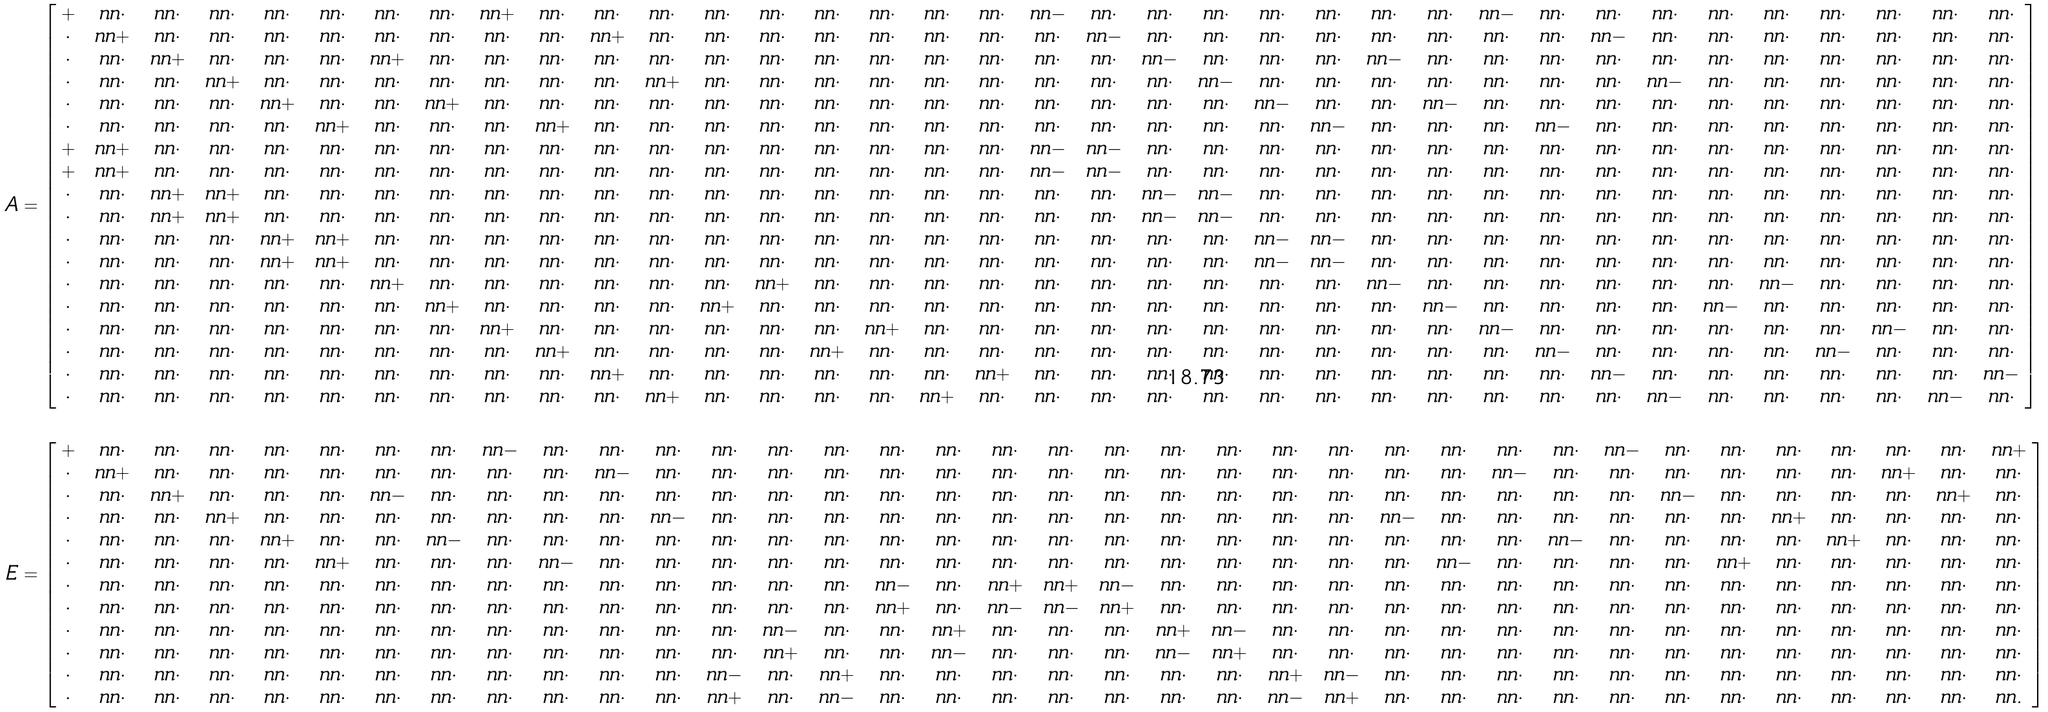<formula> <loc_0><loc_0><loc_500><loc_500>A & = \left [ \begin{array} { c c c c c c c c c c c c c c c c c c c c c c c c c c c c c c c c c c c c } + & \ n n \cdot & \ n n \cdot & \ n n \cdot & \ n n \cdot & \ n n \cdot & \ n n \cdot & \ n n \cdot & \ n n + & \ n n \cdot & \ n n \cdot & \ n n \cdot & \ n n \cdot & \ n n \cdot & \ n n \cdot & \ n n \cdot & \ n n \cdot & \ n n \cdot & \ n n - & \ n n \cdot & \ n n \cdot & \ n n \cdot & \ n n \cdot & \ n n \cdot & \ n n \cdot & \ n n \cdot & \ n n - & \ n n \cdot & \ n n \cdot & \ n n \cdot & \ n n \cdot & \ n n \cdot & \ n n \cdot & \ n n \cdot & \ n n \cdot & \ n n \cdot \\ \cdot & \ n n + & \ n n \cdot & \ n n \cdot & \ n n \cdot & \ n n \cdot & \ n n \cdot & \ n n \cdot & \ n n \cdot & \ n n \cdot & \ n n + & \ n n \cdot & \ n n \cdot & \ n n \cdot & \ n n \cdot & \ n n \cdot & \ n n \cdot & \ n n \cdot & \ n n \cdot & \ n n - & \ n n \cdot & \ n n \cdot & \ n n \cdot & \ n n \cdot & \ n n \cdot & \ n n \cdot & \ n n \cdot & \ n n \cdot & \ n n - & \ n n \cdot & \ n n \cdot & \ n n \cdot & \ n n \cdot & \ n n \cdot & \ n n \cdot & \ n n \cdot \\ \cdot & \ n n \cdot & \ n n + & \ n n \cdot & \ n n \cdot & \ n n \cdot & \ n n + & \ n n \cdot & \ n n \cdot & \ n n \cdot & \ n n \cdot & \ n n \cdot & \ n n \cdot & \ n n \cdot & \ n n \cdot & \ n n \cdot & \ n n \cdot & \ n n \cdot & \ n n \cdot & \ n n \cdot & \ n n - & \ n n \cdot & \ n n \cdot & \ n n \cdot & \ n n - & \ n n \cdot & \ n n \cdot & \ n n \cdot & \ n n \cdot & \ n n \cdot & \ n n \cdot & \ n n \cdot & \ n n \cdot & \ n n \cdot & \ n n \cdot & \ n n \cdot \\ \cdot & \ n n \cdot & \ n n \cdot & \ n n + & \ n n \cdot & \ n n \cdot & \ n n \cdot & \ n n \cdot & \ n n \cdot & \ n n \cdot & \ n n \cdot & \ n n + & \ n n \cdot & \ n n \cdot & \ n n \cdot & \ n n \cdot & \ n n \cdot & \ n n \cdot & \ n n \cdot & \ n n \cdot & \ n n \cdot & \ n n - & \ n n \cdot & \ n n \cdot & \ n n \cdot & \ n n \cdot & \ n n \cdot & \ n n \cdot & \ n n \cdot & \ n n - & \ n n \cdot & \ n n \cdot & \ n n \cdot & \ n n \cdot & \ n n \cdot & \ n n \cdot \\ \cdot & \ n n \cdot & \ n n \cdot & \ n n \cdot & \ n n + & \ n n \cdot & \ n n \cdot & \ n n + & \ n n \cdot & \ n n \cdot & \ n n \cdot & \ n n \cdot & \ n n \cdot & \ n n \cdot & \ n n \cdot & \ n n \cdot & \ n n \cdot & \ n n \cdot & \ n n \cdot & \ n n \cdot & \ n n \cdot & \ n n \cdot & \ n n - & \ n n \cdot & \ n n \cdot & \ n n - & \ n n \cdot & \ n n \cdot & \ n n \cdot & \ n n \cdot & \ n n \cdot & \ n n \cdot & \ n n \cdot & \ n n \cdot & \ n n \cdot & \ n n \cdot \\ \cdot & \ n n \cdot & \ n n \cdot & \ n n \cdot & \ n n \cdot & \ n n + & \ n n \cdot & \ n n \cdot & \ n n \cdot & \ n n + & \ n n \cdot & \ n n \cdot & \ n n \cdot & \ n n \cdot & \ n n \cdot & \ n n \cdot & \ n n \cdot & \ n n \cdot & \ n n \cdot & \ n n \cdot & \ n n \cdot & \ n n \cdot & \ n n \cdot & \ n n - & \ n n \cdot & \ n n \cdot & \ n n \cdot & \ n n - & \ n n \cdot & \ n n \cdot & \ n n \cdot & \ n n \cdot & \ n n \cdot & \ n n \cdot & \ n n \cdot & \ n n \cdot \\ + & \ n n + & \ n n \cdot & \ n n \cdot & \ n n \cdot & \ n n \cdot & \ n n \cdot & \ n n \cdot & \ n n \cdot & \ n n \cdot & \ n n \cdot & \ n n \cdot & \ n n \cdot & \ n n \cdot & \ n n \cdot & \ n n \cdot & \ n n \cdot & \ n n \cdot & \ n n - & \ n n - & \ n n \cdot & \ n n \cdot & \ n n \cdot & \ n n \cdot & \ n n \cdot & \ n n \cdot & \ n n \cdot & \ n n \cdot & \ n n \cdot & \ n n \cdot & \ n n \cdot & \ n n \cdot & \ n n \cdot & \ n n \cdot & \ n n \cdot & \ n n \cdot \\ + & \ n n + & \ n n \cdot & \ n n \cdot & \ n n \cdot & \ n n \cdot & \ n n \cdot & \ n n \cdot & \ n n \cdot & \ n n \cdot & \ n n \cdot & \ n n \cdot & \ n n \cdot & \ n n \cdot & \ n n \cdot & \ n n \cdot & \ n n \cdot & \ n n \cdot & \ n n - & \ n n - & \ n n \cdot & \ n n \cdot & \ n n \cdot & \ n n \cdot & \ n n \cdot & \ n n \cdot & \ n n \cdot & \ n n \cdot & \ n n \cdot & \ n n \cdot & \ n n \cdot & \ n n \cdot & \ n n \cdot & \ n n \cdot & \ n n \cdot & \ n n \cdot \\ \cdot & \ n n \cdot & \ n n + & \ n n + & \ n n \cdot & \ n n \cdot & \ n n \cdot & \ n n \cdot & \ n n \cdot & \ n n \cdot & \ n n \cdot & \ n n \cdot & \ n n \cdot & \ n n \cdot & \ n n \cdot & \ n n \cdot & \ n n \cdot & \ n n \cdot & \ n n \cdot & \ n n \cdot & \ n n - & \ n n - & \ n n \cdot & \ n n \cdot & \ n n \cdot & \ n n \cdot & \ n n \cdot & \ n n \cdot & \ n n \cdot & \ n n \cdot & \ n n \cdot & \ n n \cdot & \ n n \cdot & \ n n \cdot & \ n n \cdot & \ n n \cdot \\ \cdot & \ n n \cdot & \ n n + & \ n n + & \ n n \cdot & \ n n \cdot & \ n n \cdot & \ n n \cdot & \ n n \cdot & \ n n \cdot & \ n n \cdot & \ n n \cdot & \ n n \cdot & \ n n \cdot & \ n n \cdot & \ n n \cdot & \ n n \cdot & \ n n \cdot & \ n n \cdot & \ n n \cdot & \ n n - & \ n n - & \ n n \cdot & \ n n \cdot & \ n n \cdot & \ n n \cdot & \ n n \cdot & \ n n \cdot & \ n n \cdot & \ n n \cdot & \ n n \cdot & \ n n \cdot & \ n n \cdot & \ n n \cdot & \ n n \cdot & \ n n \cdot \\ \cdot & \ n n \cdot & \ n n \cdot & \ n n \cdot & \ n n + & \ n n + & \ n n \cdot & \ n n \cdot & \ n n \cdot & \ n n \cdot & \ n n \cdot & \ n n \cdot & \ n n \cdot & \ n n \cdot & \ n n \cdot & \ n n \cdot & \ n n \cdot & \ n n \cdot & \ n n \cdot & \ n n \cdot & \ n n \cdot & \ n n \cdot & \ n n - & \ n n - & \ n n \cdot & \ n n \cdot & \ n n \cdot & \ n n \cdot & \ n n \cdot & \ n n \cdot & \ n n \cdot & \ n n \cdot & \ n n \cdot & \ n n \cdot & \ n n \cdot & \ n n \cdot \\ \cdot & \ n n \cdot & \ n n \cdot & \ n n \cdot & \ n n + & \ n n + & \ n n \cdot & \ n n \cdot & \ n n \cdot & \ n n \cdot & \ n n \cdot & \ n n \cdot & \ n n \cdot & \ n n \cdot & \ n n \cdot & \ n n \cdot & \ n n \cdot & \ n n \cdot & \ n n \cdot & \ n n \cdot & \ n n \cdot & \ n n \cdot & \ n n - & \ n n - & \ n n \cdot & \ n n \cdot & \ n n \cdot & \ n n \cdot & \ n n \cdot & \ n n \cdot & \ n n \cdot & \ n n \cdot & \ n n \cdot & \ n n \cdot & \ n n \cdot & \ n n \cdot \\ \cdot & \ n n \cdot & \ n n \cdot & \ n n \cdot & \ n n \cdot & \ n n \cdot & \ n n + & \ n n \cdot & \ n n \cdot & \ n n \cdot & \ n n \cdot & \ n n \cdot & \ n n \cdot & \ n n + & \ n n \cdot & \ n n \cdot & \ n n \cdot & \ n n \cdot & \ n n \cdot & \ n n \cdot & \ n n \cdot & \ n n \cdot & \ n n \cdot & \ n n \cdot & \ n n - & \ n n \cdot & \ n n \cdot & \ n n \cdot & \ n n \cdot & \ n n \cdot & \ n n \cdot & \ n n - & \ n n \cdot & \ n n \cdot & \ n n \cdot & \ n n \cdot \\ \cdot & \ n n \cdot & \ n n \cdot & \ n n \cdot & \ n n \cdot & \ n n \cdot & \ n n \cdot & \ n n + & \ n n \cdot & \ n n \cdot & \ n n \cdot & \ n n \cdot & \ n n + & \ n n \cdot & \ n n \cdot & \ n n \cdot & \ n n \cdot & \ n n \cdot & \ n n \cdot & \ n n \cdot & \ n n \cdot & \ n n \cdot & \ n n \cdot & \ n n \cdot & \ n n \cdot & \ n n - & \ n n \cdot & \ n n \cdot & \ n n \cdot & \ n n \cdot & \ n n - & \ n n \cdot & \ n n \cdot & \ n n \cdot & \ n n \cdot & \ n n \cdot \\ \cdot & \ n n \cdot & \ n n \cdot & \ n n \cdot & \ n n \cdot & \ n n \cdot & \ n n \cdot & \ n n \cdot & \ n n + & \ n n \cdot & \ n n \cdot & \ n n \cdot & \ n n \cdot & \ n n \cdot & \ n n \cdot & \ n n + & \ n n \cdot & \ n n \cdot & \ n n \cdot & \ n n \cdot & \ n n \cdot & \ n n \cdot & \ n n \cdot & \ n n \cdot & \ n n \cdot & \ n n \cdot & \ n n - & \ n n \cdot & \ n n \cdot & \ n n \cdot & \ n n \cdot & \ n n \cdot & \ n n \cdot & \ n n - & \ n n \cdot & \ n n \cdot \\ \cdot & \ n n \cdot & \ n n \cdot & \ n n \cdot & \ n n \cdot & \ n n \cdot & \ n n \cdot & \ n n \cdot & \ n n \cdot & \ n n + & \ n n \cdot & \ n n \cdot & \ n n \cdot & \ n n \cdot & \ n n + & \ n n \cdot & \ n n \cdot & \ n n \cdot & \ n n \cdot & \ n n \cdot & \ n n \cdot & \ n n \cdot & \ n n \cdot & \ n n \cdot & \ n n \cdot & \ n n \cdot & \ n n \cdot & \ n n - & \ n n \cdot & \ n n \cdot & \ n n \cdot & \ n n \cdot & \ n n - & \ n n \cdot & \ n n \cdot & \ n n \cdot \\ \cdot & \ n n \cdot & \ n n \cdot & \ n n \cdot & \ n n \cdot & \ n n \cdot & \ n n \cdot & \ n n \cdot & \ n n \cdot & \ n n \cdot & \ n n + & \ n n \cdot & \ n n \cdot & \ n n \cdot & \ n n \cdot & \ n n \cdot & \ n n \cdot & \ n n + & \ n n \cdot & \ n n \cdot & \ n n \cdot & \ n n \cdot & \ n n \cdot & \ n n \cdot & \ n n \cdot & \ n n \cdot & \ n n \cdot & \ n n \cdot & \ n n - & \ n n \cdot & \ n n \cdot & \ n n \cdot & \ n n \cdot & \ n n \cdot & \ n n \cdot & \ n n - \\ \cdot & \ n n \cdot & \ n n \cdot & \ n n \cdot & \ n n \cdot & \ n n \cdot & \ n n \cdot & \ n n \cdot & \ n n \cdot & \ n n \cdot & \ n n \cdot & \ n n + & \ n n \cdot & \ n n \cdot & \ n n \cdot & \ n n \cdot & \ n n + & \ n n \cdot & \ n n \cdot & \ n n \cdot & \ n n \cdot & \ n n \cdot & \ n n \cdot & \ n n \cdot & \ n n \cdot & \ n n \cdot & \ n n \cdot & \ n n \cdot & \ n n \cdot & \ n n - & \ n n \cdot & \ n n \cdot & \ n n \cdot & \ n n \cdot & \ n n - & \ n n \cdot \end{array} \right ] \\ \\ E & = \left [ \begin{array} { c c c c c c c c c c c c c c c c c c c c c c c c c c c c c c c c c c c c } + & \ n n \cdot & \ n n \cdot & \ n n \cdot & \ n n \cdot & \ n n \cdot & \ n n \cdot & \ n n \cdot & \ n n - & \ n n \cdot & \ n n \cdot & \ n n \cdot & \ n n \cdot & \ n n \cdot & \ n n \cdot & \ n n \cdot & \ n n \cdot & \ n n \cdot & \ n n \cdot & \ n n \cdot & \ n n \cdot & \ n n \cdot & \ n n \cdot & \ n n \cdot & \ n n \cdot & \ n n \cdot & \ n n \cdot & \ n n \cdot & \ n n - & \ n n \cdot & \ n n \cdot & \ n n \cdot & \ n n \cdot & \ n n \cdot & \ n n \cdot & \ n n + \\ \cdot & \ n n + & \ n n \cdot & \ n n \cdot & \ n n \cdot & \ n n \cdot & \ n n \cdot & \ n n \cdot & \ n n \cdot & \ n n \cdot & \ n n - & \ n n \cdot & \ n n \cdot & \ n n \cdot & \ n n \cdot & \ n n \cdot & \ n n \cdot & \ n n \cdot & \ n n \cdot & \ n n \cdot & \ n n \cdot & \ n n \cdot & \ n n \cdot & \ n n \cdot & \ n n \cdot & \ n n \cdot & \ n n - & \ n n \cdot & \ n n \cdot & \ n n \cdot & \ n n \cdot & \ n n \cdot & \ n n \cdot & \ n n + & \ n n \cdot & \ n n \cdot \\ \cdot & \ n n \cdot & \ n n + & \ n n \cdot & \ n n \cdot & \ n n \cdot & \ n n - & \ n n \cdot & \ n n \cdot & \ n n \cdot & \ n n \cdot & \ n n \cdot & \ n n \cdot & \ n n \cdot & \ n n \cdot & \ n n \cdot & \ n n \cdot & \ n n \cdot & \ n n \cdot & \ n n \cdot & \ n n \cdot & \ n n \cdot & \ n n \cdot & \ n n \cdot & \ n n \cdot & \ n n \cdot & \ n n \cdot & \ n n \cdot & \ n n \cdot & \ n n - & \ n n \cdot & \ n n \cdot & \ n n \cdot & \ n n \cdot & \ n n + & \ n n \cdot \\ \cdot & \ n n \cdot & \ n n \cdot & \ n n + & \ n n \cdot & \ n n \cdot & \ n n \cdot & \ n n \cdot & \ n n \cdot & \ n n \cdot & \ n n \cdot & \ n n - & \ n n \cdot & \ n n \cdot & \ n n \cdot & \ n n \cdot & \ n n \cdot & \ n n \cdot & \ n n \cdot & \ n n \cdot & \ n n \cdot & \ n n \cdot & \ n n \cdot & \ n n \cdot & \ n n - & \ n n \cdot & \ n n \cdot & \ n n \cdot & \ n n \cdot & \ n n \cdot & \ n n \cdot & \ n n + & \ n n \cdot & \ n n \cdot & \ n n \cdot & \ n n \cdot \\ \cdot & \ n n \cdot & \ n n \cdot & \ n n \cdot & \ n n + & \ n n \cdot & \ n n \cdot & \ n n - & \ n n \cdot & \ n n \cdot & \ n n \cdot & \ n n \cdot & \ n n \cdot & \ n n \cdot & \ n n \cdot & \ n n \cdot & \ n n \cdot & \ n n \cdot & \ n n \cdot & \ n n \cdot & \ n n \cdot & \ n n \cdot & \ n n \cdot & \ n n \cdot & \ n n \cdot & \ n n \cdot & \ n n \cdot & \ n n - & \ n n \cdot & \ n n \cdot & \ n n \cdot & \ n n \cdot & \ n n + & \ n n \cdot & \ n n \cdot & \ n n \cdot \\ \cdot & \ n n \cdot & \ n n \cdot & \ n n \cdot & \ n n \cdot & \ n n + & \ n n \cdot & \ n n \cdot & \ n n \cdot & \ n n - & \ n n \cdot & \ n n \cdot & \ n n \cdot & \ n n \cdot & \ n n \cdot & \ n n \cdot & \ n n \cdot & \ n n \cdot & \ n n \cdot & \ n n \cdot & \ n n \cdot & \ n n \cdot & \ n n \cdot & \ n n \cdot & \ n n \cdot & \ n n - & \ n n \cdot & \ n n \cdot & \ n n \cdot & \ n n \cdot & \ n n + & \ n n \cdot & \ n n \cdot & \ n n \cdot & \ n n \cdot & \ n n \cdot \\ \cdot & \ n n \cdot & \ n n \cdot & \ n n \cdot & \ n n \cdot & \ n n \cdot & \ n n \cdot & \ n n \cdot & \ n n \cdot & \ n n \cdot & \ n n \cdot & \ n n \cdot & \ n n \cdot & \ n n \cdot & \ n n \cdot & \ n n - & \ n n \cdot & \ n n + & \ n n + & \ n n - & \ n n \cdot & \ n n \cdot & \ n n \cdot & \ n n \cdot & \ n n \cdot & \ n n \cdot & \ n n \cdot & \ n n \cdot & \ n n \cdot & \ n n \cdot & \ n n \cdot & \ n n \cdot & \ n n \cdot & \ n n \cdot & \ n n \cdot & \ n n \cdot \\ \cdot & \ n n \cdot & \ n n \cdot & \ n n \cdot & \ n n \cdot & \ n n \cdot & \ n n \cdot & \ n n \cdot & \ n n \cdot & \ n n \cdot & \ n n \cdot & \ n n \cdot & \ n n \cdot & \ n n \cdot & \ n n \cdot & \ n n + & \ n n \cdot & \ n n - & \ n n - & \ n n + & \ n n \cdot & \ n n \cdot & \ n n \cdot & \ n n \cdot & \ n n \cdot & \ n n \cdot & \ n n \cdot & \ n n \cdot & \ n n \cdot & \ n n \cdot & \ n n \cdot & \ n n \cdot & \ n n \cdot & \ n n \cdot & \ n n \cdot & \ n n \cdot \\ \cdot & \ n n \cdot & \ n n \cdot & \ n n \cdot & \ n n \cdot & \ n n \cdot & \ n n \cdot & \ n n \cdot & \ n n \cdot & \ n n \cdot & \ n n \cdot & \ n n \cdot & \ n n \cdot & \ n n - & \ n n \cdot & \ n n \cdot & \ n n + & \ n n \cdot & \ n n \cdot & \ n n \cdot & \ n n + & \ n n - & \ n n \cdot & \ n n \cdot & \ n n \cdot & \ n n \cdot & \ n n \cdot & \ n n \cdot & \ n n \cdot & \ n n \cdot & \ n n \cdot & \ n n \cdot & \ n n \cdot & \ n n \cdot & \ n n \cdot & \ n n \cdot \\ \cdot & \ n n \cdot & \ n n \cdot & \ n n \cdot & \ n n \cdot & \ n n \cdot & \ n n \cdot & \ n n \cdot & \ n n \cdot & \ n n \cdot & \ n n \cdot & \ n n \cdot & \ n n \cdot & \ n n + & \ n n \cdot & \ n n \cdot & \ n n - & \ n n \cdot & \ n n \cdot & \ n n \cdot & \ n n - & \ n n + & \ n n \cdot & \ n n \cdot & \ n n \cdot & \ n n \cdot & \ n n \cdot & \ n n \cdot & \ n n \cdot & \ n n \cdot & \ n n \cdot & \ n n \cdot & \ n n \cdot & \ n n \cdot & \ n n \cdot & \ n n \cdot \\ \cdot & \ n n \cdot & \ n n \cdot & \ n n \cdot & \ n n \cdot & \ n n \cdot & \ n n \cdot & \ n n \cdot & \ n n \cdot & \ n n \cdot & \ n n \cdot & \ n n \cdot & \ n n - & \ n n \cdot & \ n n + & \ n n \cdot & \ n n \cdot & \ n n \cdot & \ n n \cdot & \ n n \cdot & \ n n \cdot & \ n n \cdot & \ n n + & \ n n - & \ n n \cdot & \ n n \cdot & \ n n \cdot & \ n n \cdot & \ n n \cdot & \ n n \cdot & \ n n \cdot & \ n n \cdot & \ n n \cdot & \ n n \cdot & \ n n \cdot & \ n n \cdot \\ \cdot & \ n n \cdot & \ n n \cdot & \ n n \cdot & \ n n \cdot & \ n n \cdot & \ n n \cdot & \ n n \cdot & \ n n \cdot & \ n n \cdot & \ n n \cdot & \ n n \cdot & \ n n + & \ n n \cdot & \ n n - & \ n n \cdot & \ n n \cdot & \ n n \cdot & \ n n \cdot & \ n n \cdot & \ n n \cdot & \ n n \cdot & \ n n - & \ n n + & \ n n \cdot & \ n n \cdot & \ n n \cdot & \ n n \cdot & \ n n \cdot & \ n n \cdot & \ n n \cdot & \ n n \cdot & \ n n \cdot & \ n n \cdot & \ n n \cdot & \ n n . \end{array} \right ]</formula> 